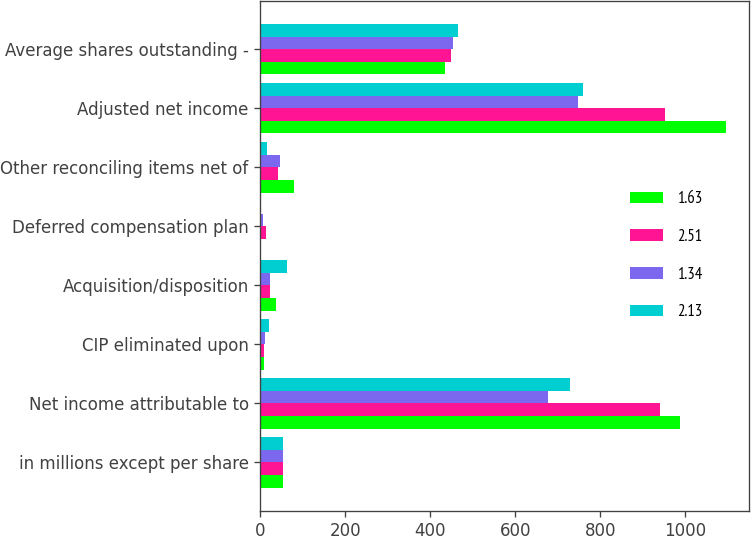Convert chart to OTSL. <chart><loc_0><loc_0><loc_500><loc_500><stacked_bar_chart><ecel><fcel>in millions except per share<fcel>Net income attributable to<fcel>CIP eliminated upon<fcel>Acquisition/disposition<fcel>Deferred compensation plan<fcel>Other reconciling items net of<fcel>Adjusted net income<fcel>Average shares outstanding -<nl><fcel>1.63<fcel>54.3<fcel>988.1<fcel>7.8<fcel>36.2<fcel>0.3<fcel>78.6<fcel>1094.8<fcel>435.6<nl><fcel>2.51<fcel>54.3<fcel>940.3<fcel>8.7<fcel>23.8<fcel>12.6<fcel>40.7<fcel>953.3<fcel>448.5<nl><fcel>1.34<fcel>54.3<fcel>677.1<fcel>10.7<fcel>21.9<fcel>7.4<fcel>46.3<fcel>748.6<fcel>453.8<nl><fcel>2.13<fcel>54.3<fcel>729.7<fcel>20.2<fcel>62.3<fcel>2.5<fcel>15.2<fcel>759.1<fcel>464.7<nl></chart> 